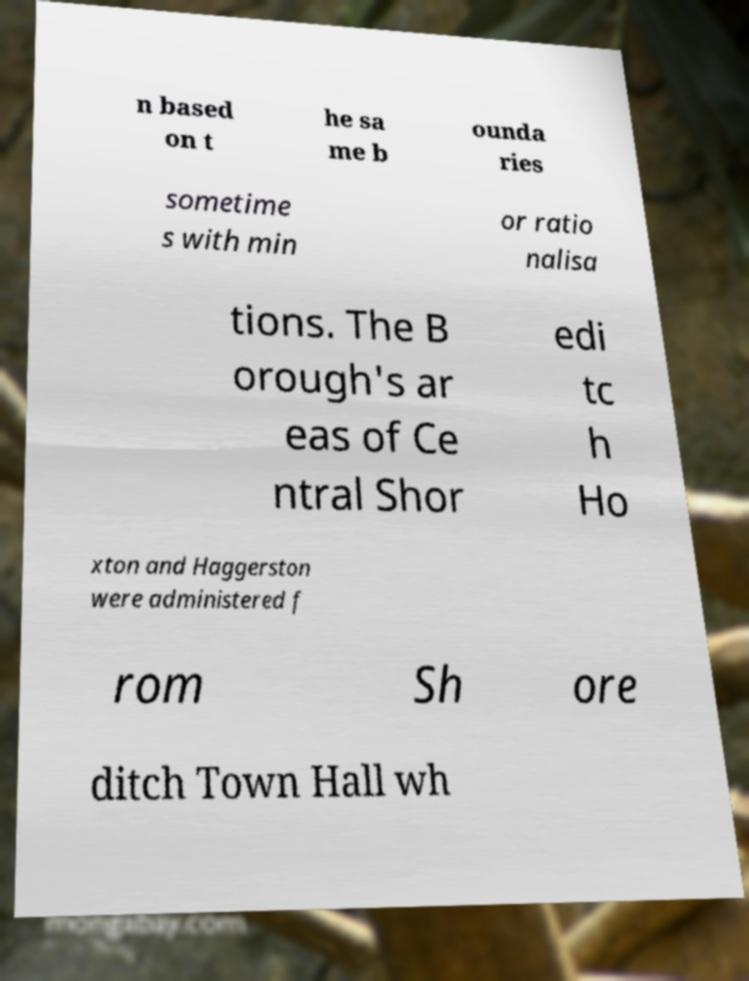Please identify and transcribe the text found in this image. n based on t he sa me b ounda ries sometime s with min or ratio nalisa tions. The B orough's ar eas of Ce ntral Shor edi tc h Ho xton and Haggerston were administered f rom Sh ore ditch Town Hall wh 